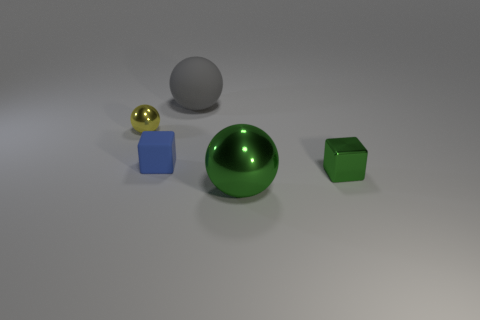Add 3 big green matte cubes. How many objects exist? 8 Subtract all spheres. How many objects are left? 2 Add 4 matte cubes. How many matte cubes exist? 5 Subtract 0 gray cylinders. How many objects are left? 5 Subtract all big objects. Subtract all tiny blue matte objects. How many objects are left? 2 Add 1 green shiny things. How many green shiny things are left? 3 